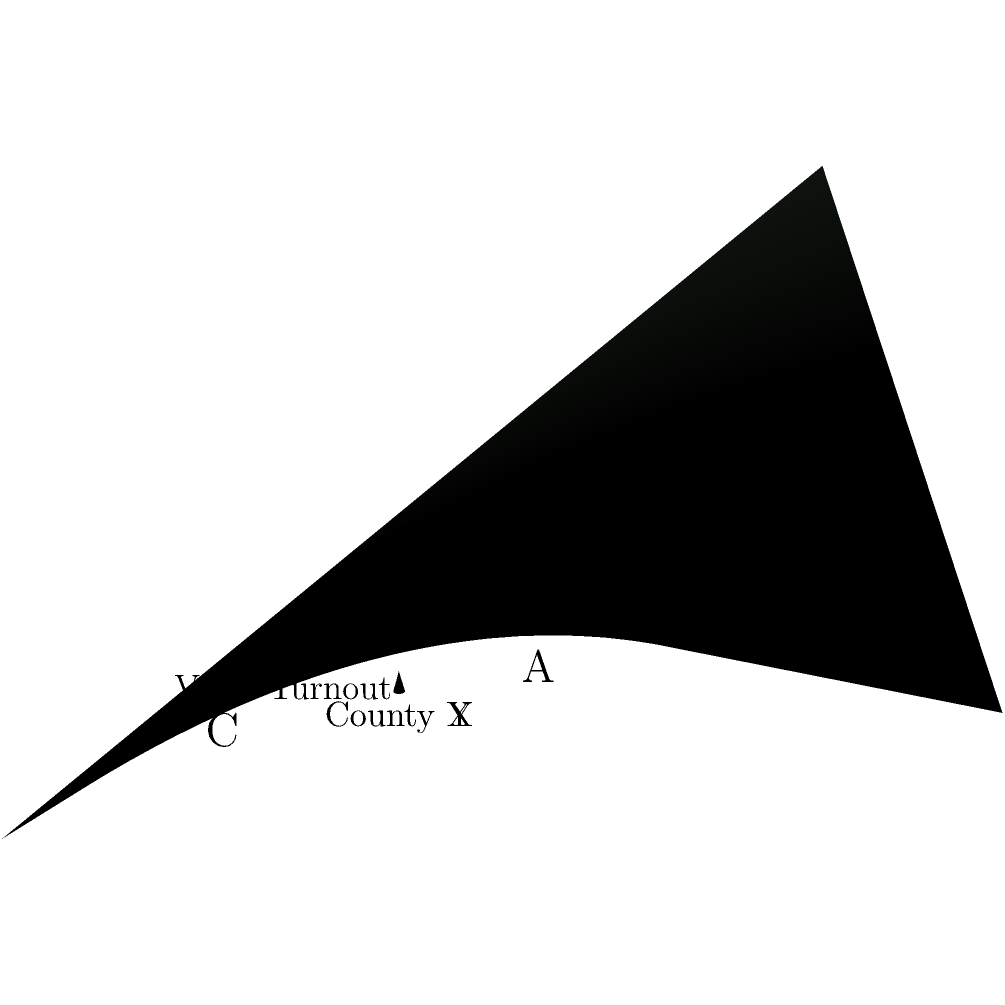In this 3D coordinate system representing voter turnout percentages across different counties, point A represents the average turnout. If the x and y axes represent two different counties, and the z-axis represents the voter turnout percentage, what can be inferred about the relationship between County X and County Y in terms of their impact on overall voter turnout? To analyze the relationship between County X and County Y and their impact on overall voter turnout, let's follow these steps:

1. Observe the shape of the surface: The surface is curved, indicating a non-linear relationship between the counties and voter turnout.

2. Locate point A: Point A (2.5, 2.5, 0.8125) represents the average turnout. It's positioned at the center of the graph, suggesting a balanced influence from both counties.

3. Analyze the slope:
   - Moving from A towards higher values of X (County X) and lower values of Y (County Y), we reach point C (4, 1, 0.7).
   - Moving from A towards lower values of X (County X) and higher values of Y (County Y), we reach point B (1, 4, 0.7).

4. Compare heights:
   - Points B and C have the same height (z-value) of 0.7, which is lower than point A (0.8125).

5. Interpret the results:
   - When one county's influence increases while the other decreases, the overall turnout decreases.
   - The highest turnout is achieved when both counties have balanced influence (point A).

6. Consider the historical context:
   As a student of Abraham Lincoln, recall his emphasis on unity and balance in democracy. This graph illustrates the importance of balanced participation across different regions for optimal voter turnout.

Therefore, the relationship between County X and County Y shows that they have a synergistic effect on voter turnout. The highest turnout is achieved when both counties have equal influence, aligning with Lincoln's vision of a united democracy.
Answer: Synergistic effect: Balanced influence from both counties yields highest turnout 